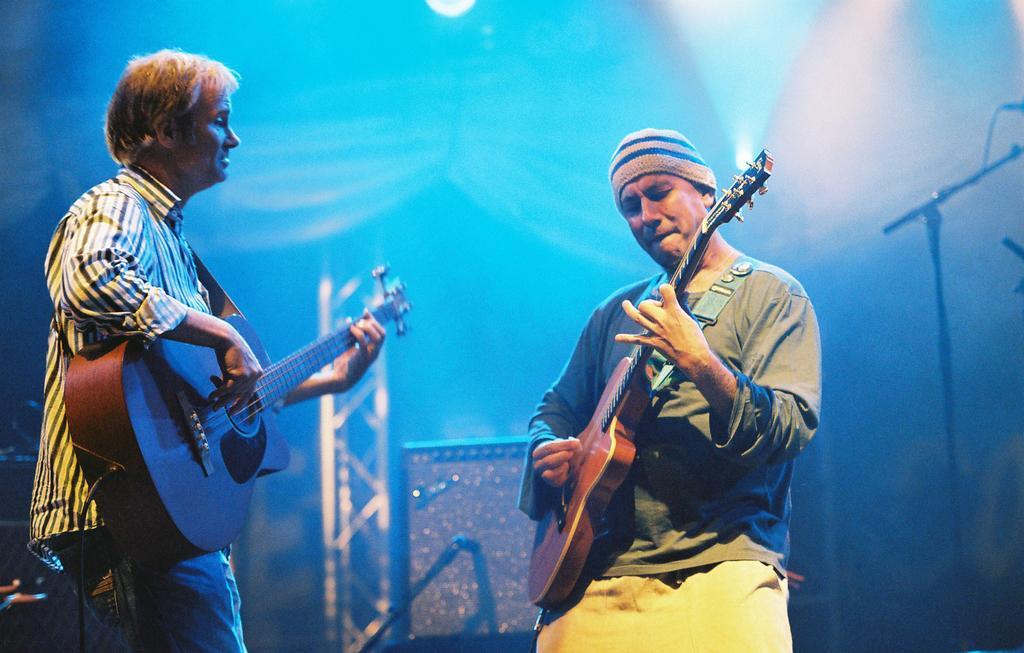In one or two sentences, can you explain what this image depicts? In this picture we can see two persons playing guitar and on right side person wore T-Shirt, cap to his head and in the background we can see some metal ladder and light. 